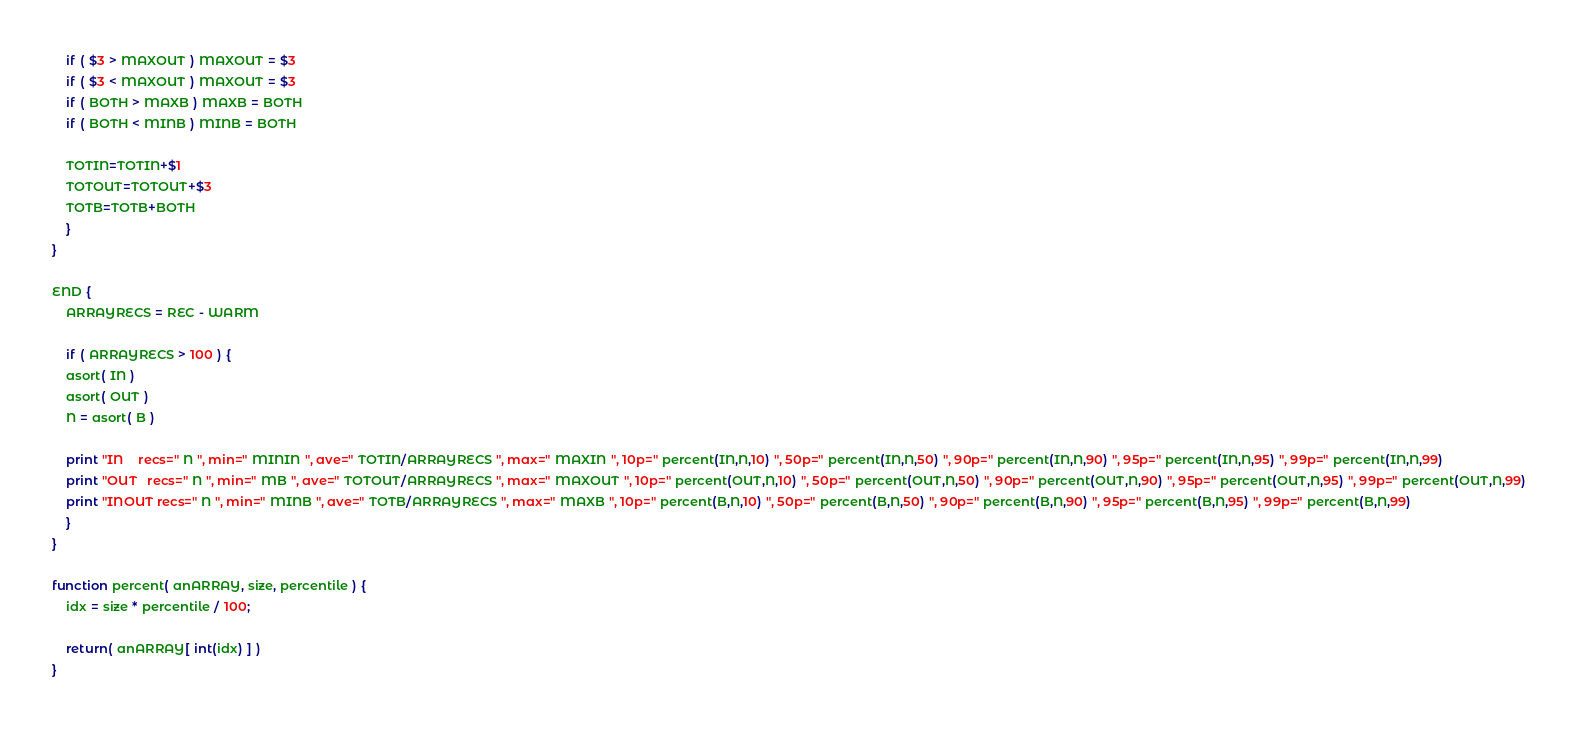<code> <loc_0><loc_0><loc_500><loc_500><_Awk_>	if ( $3 > MAXOUT ) MAXOUT = $3
	if ( $3 < MAXOUT ) MAXOUT = $3
	if ( BOTH > MAXB ) MAXB = BOTH
	if ( BOTH < MINB ) MINB = BOTH

	TOTIN=TOTIN+$1
	TOTOUT=TOTOUT+$3
	TOTB=TOTB+BOTH
    }
}

END {
    ARRAYRECS = REC - WARM

    if ( ARRAYRECS > 100 ) {
	asort( IN )
	asort( OUT )
	N = asort( B )

	print "IN    recs=" N ", min=" MININ ", ave=" TOTIN/ARRAYRECS ", max=" MAXIN ", 10p=" percent(IN,N,10) ", 50p=" percent(IN,N,50) ", 90p=" percent(IN,N,90) ", 95p=" percent(IN,N,95) ", 99p=" percent(IN,N,99)
	print "OUT   recs=" N ", min=" MB ", ave=" TOTOUT/ARRAYRECS ", max=" MAXOUT ", 10p=" percent(OUT,N,10) ", 50p=" percent(OUT,N,50) ", 90p=" percent(OUT,N,90) ", 95p=" percent(OUT,N,95) ", 99p=" percent(OUT,N,99)
	print "INOUT recs=" N ", min=" MINB ", ave=" TOTB/ARRAYRECS ", max=" MAXB ", 10p=" percent(B,N,10) ", 50p=" percent(B,N,50) ", 90p=" percent(B,N,90) ", 95p=" percent(B,N,95) ", 99p=" percent(B,N,99)
    }
}

function percent( anARRAY, size, percentile ) {
	idx = size * percentile / 100;

	return( anARRAY[ int(idx) ] )
}

</code> 